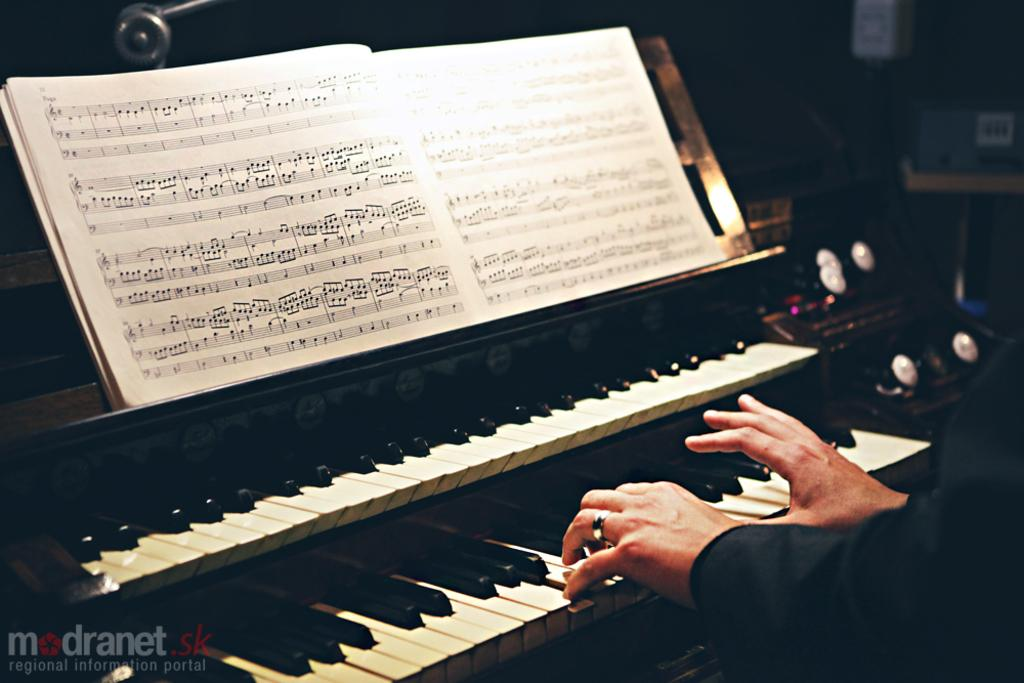What is the person in the image doing? The person is playing a piano keyboard. Can you describe any additional objects in the image? Yes, there is a book on the piano. What color is the underwear of the person playing the piano keyboard in the image? There is no information about the person's underwear in the image, so we cannot determine its color. 